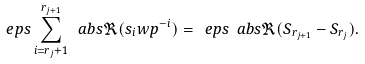Convert formula to latex. <formula><loc_0><loc_0><loc_500><loc_500>\ e p s \sum _ { i = r _ { j } + 1 } ^ { r _ { j + 1 } } \ a b s { \Re ( s _ { i } w p ^ { - i } ) } = \ e p s \ a b s { \Re ( S _ { r _ { j + 1 } } - S _ { r _ { j } } ) } .</formula> 